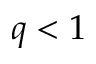<formula> <loc_0><loc_0><loc_500><loc_500>q < 1</formula> 